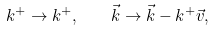Convert formula to latex. <formula><loc_0><loc_0><loc_500><loc_500>k ^ { + } \to k ^ { + } , \quad \vec { k } \to \vec { k } - k ^ { + } \vec { v } ,</formula> 